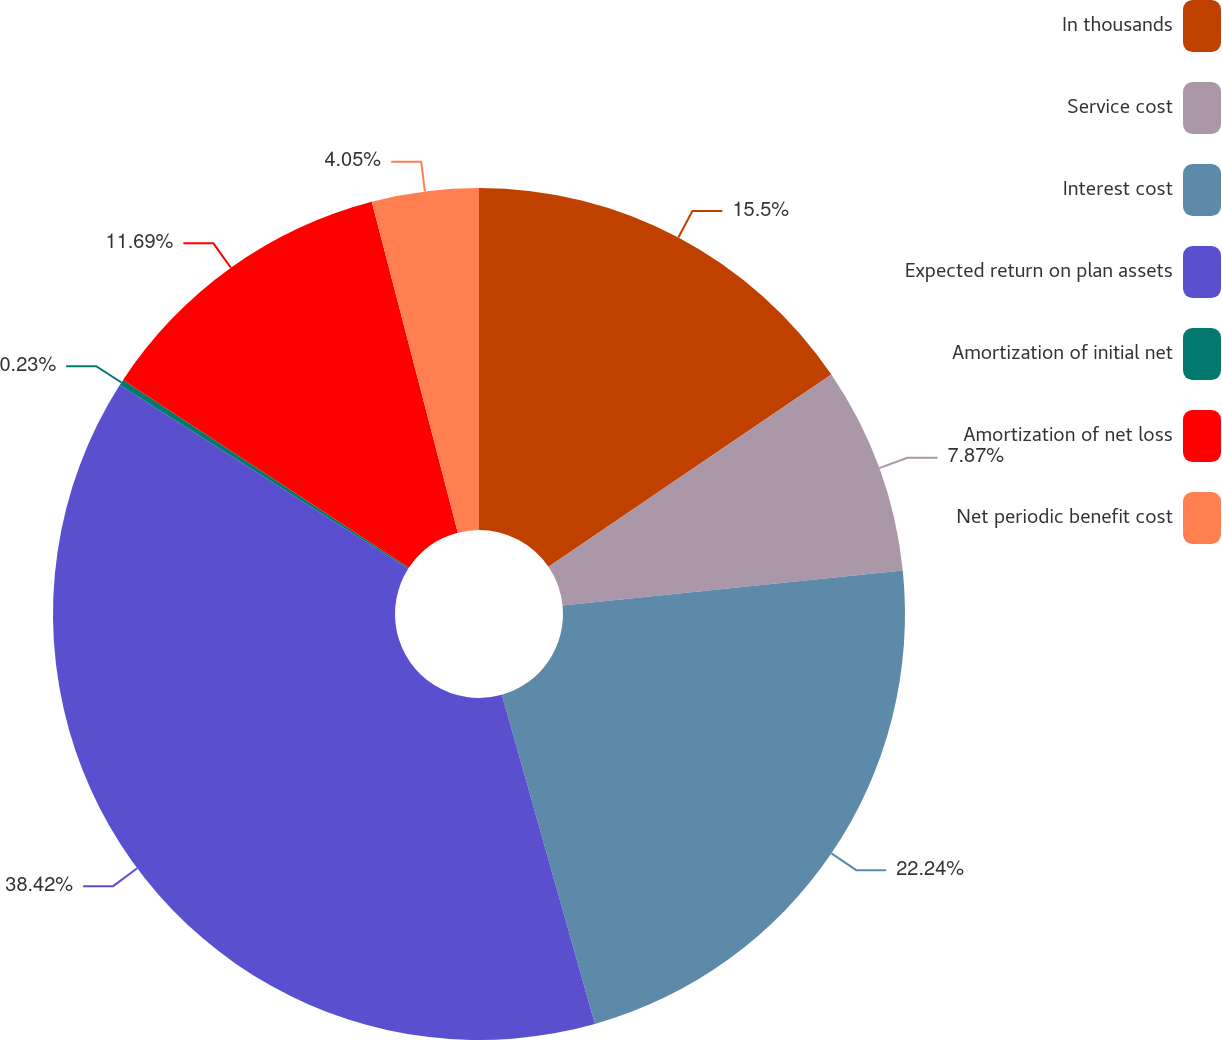<chart> <loc_0><loc_0><loc_500><loc_500><pie_chart><fcel>In thousands<fcel>Service cost<fcel>Interest cost<fcel>Expected return on plan assets<fcel>Amortization of initial net<fcel>Amortization of net loss<fcel>Net periodic benefit cost<nl><fcel>15.5%<fcel>7.87%<fcel>22.24%<fcel>38.41%<fcel>0.23%<fcel>11.69%<fcel>4.05%<nl></chart> 